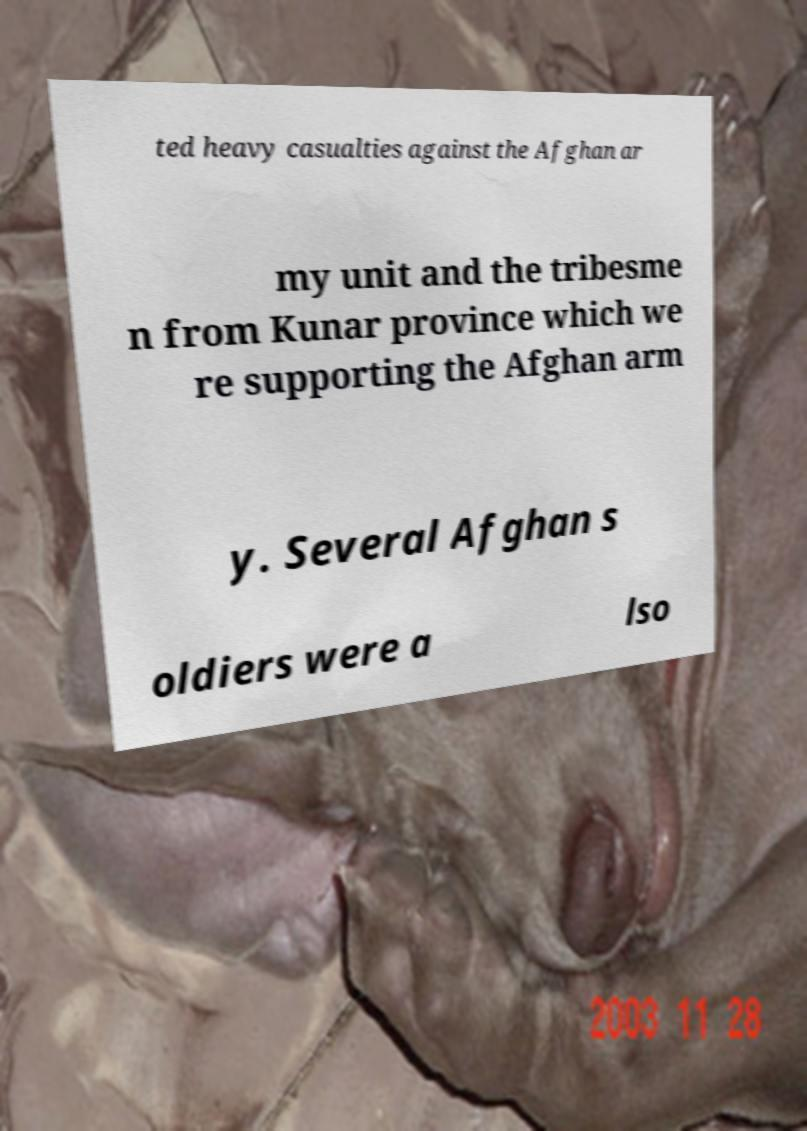Can you accurately transcribe the text from the provided image for me? ted heavy casualties against the Afghan ar my unit and the tribesme n from Kunar province which we re supporting the Afghan arm y. Several Afghan s oldiers were a lso 